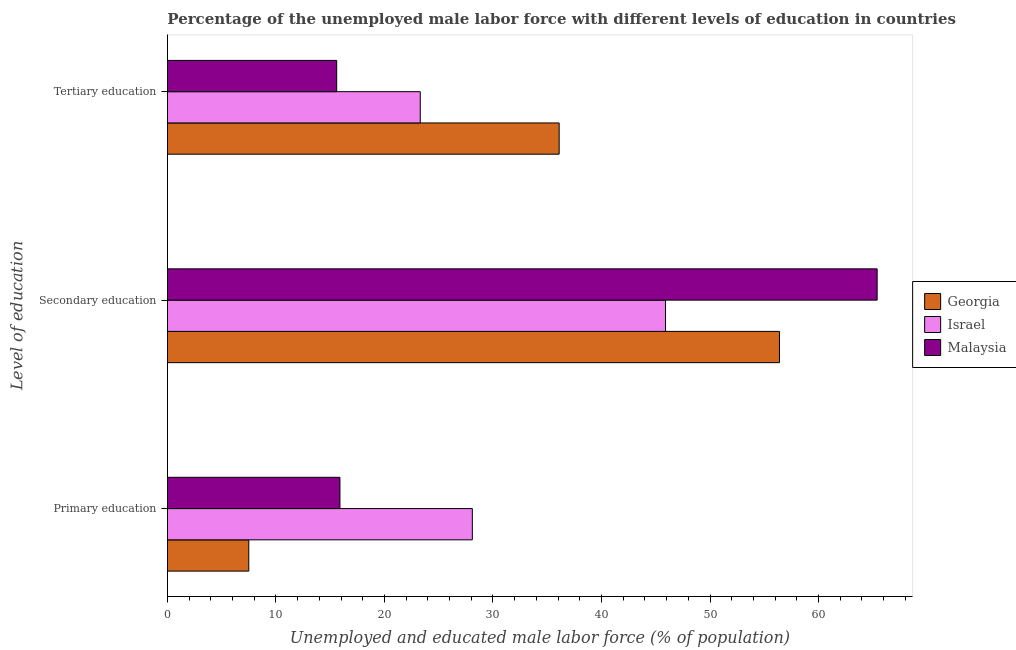How many different coloured bars are there?
Keep it short and to the point. 3. How many groups of bars are there?
Provide a short and direct response. 3. What is the percentage of male labor force who received tertiary education in Israel?
Provide a succinct answer. 23.3. Across all countries, what is the maximum percentage of male labor force who received secondary education?
Provide a succinct answer. 65.4. In which country was the percentage of male labor force who received secondary education maximum?
Offer a terse response. Malaysia. In which country was the percentage of male labor force who received primary education minimum?
Your response must be concise. Georgia. What is the total percentage of male labor force who received primary education in the graph?
Give a very brief answer. 51.5. What is the difference between the percentage of male labor force who received tertiary education in Israel and that in Malaysia?
Your answer should be compact. 7.7. What is the difference between the percentage of male labor force who received primary education in Georgia and the percentage of male labor force who received tertiary education in Israel?
Offer a terse response. -15.8. What is the average percentage of male labor force who received secondary education per country?
Your answer should be compact. 55.9. What is the difference between the percentage of male labor force who received primary education and percentage of male labor force who received secondary education in Malaysia?
Provide a succinct answer. -49.5. In how many countries, is the percentage of male labor force who received primary education greater than 32 %?
Offer a very short reply. 0. What is the ratio of the percentage of male labor force who received secondary education in Malaysia to that in Israel?
Keep it short and to the point. 1.42. Is the difference between the percentage of male labor force who received tertiary education in Malaysia and Georgia greater than the difference between the percentage of male labor force who received secondary education in Malaysia and Georgia?
Provide a short and direct response. No. What is the difference between the highest and the second highest percentage of male labor force who received tertiary education?
Your answer should be very brief. 12.8. What is the difference between the highest and the lowest percentage of male labor force who received secondary education?
Keep it short and to the point. 19.5. What does the 1st bar from the bottom in Primary education represents?
Provide a short and direct response. Georgia. Is it the case that in every country, the sum of the percentage of male labor force who received primary education and percentage of male labor force who received secondary education is greater than the percentage of male labor force who received tertiary education?
Your response must be concise. Yes. How many bars are there?
Give a very brief answer. 9. What is the difference between two consecutive major ticks on the X-axis?
Your answer should be very brief. 10. Does the graph contain any zero values?
Your response must be concise. No. Does the graph contain grids?
Your answer should be very brief. No. Where does the legend appear in the graph?
Your response must be concise. Center right. How are the legend labels stacked?
Your answer should be very brief. Vertical. What is the title of the graph?
Offer a terse response. Percentage of the unemployed male labor force with different levels of education in countries. Does "Germany" appear as one of the legend labels in the graph?
Give a very brief answer. No. What is the label or title of the X-axis?
Ensure brevity in your answer.  Unemployed and educated male labor force (% of population). What is the label or title of the Y-axis?
Provide a short and direct response. Level of education. What is the Unemployed and educated male labor force (% of population) of Georgia in Primary education?
Ensure brevity in your answer.  7.5. What is the Unemployed and educated male labor force (% of population) in Israel in Primary education?
Ensure brevity in your answer.  28.1. What is the Unemployed and educated male labor force (% of population) in Malaysia in Primary education?
Keep it short and to the point. 15.9. What is the Unemployed and educated male labor force (% of population) in Georgia in Secondary education?
Give a very brief answer. 56.4. What is the Unemployed and educated male labor force (% of population) of Israel in Secondary education?
Your response must be concise. 45.9. What is the Unemployed and educated male labor force (% of population) in Malaysia in Secondary education?
Offer a terse response. 65.4. What is the Unemployed and educated male labor force (% of population) of Georgia in Tertiary education?
Your answer should be compact. 36.1. What is the Unemployed and educated male labor force (% of population) in Israel in Tertiary education?
Your answer should be compact. 23.3. What is the Unemployed and educated male labor force (% of population) of Malaysia in Tertiary education?
Your answer should be very brief. 15.6. Across all Level of education, what is the maximum Unemployed and educated male labor force (% of population) of Georgia?
Keep it short and to the point. 56.4. Across all Level of education, what is the maximum Unemployed and educated male labor force (% of population) of Israel?
Provide a short and direct response. 45.9. Across all Level of education, what is the maximum Unemployed and educated male labor force (% of population) of Malaysia?
Offer a very short reply. 65.4. Across all Level of education, what is the minimum Unemployed and educated male labor force (% of population) in Georgia?
Your answer should be very brief. 7.5. Across all Level of education, what is the minimum Unemployed and educated male labor force (% of population) in Israel?
Your response must be concise. 23.3. Across all Level of education, what is the minimum Unemployed and educated male labor force (% of population) of Malaysia?
Provide a short and direct response. 15.6. What is the total Unemployed and educated male labor force (% of population) of Israel in the graph?
Give a very brief answer. 97.3. What is the total Unemployed and educated male labor force (% of population) in Malaysia in the graph?
Your answer should be compact. 96.9. What is the difference between the Unemployed and educated male labor force (% of population) in Georgia in Primary education and that in Secondary education?
Your answer should be compact. -48.9. What is the difference between the Unemployed and educated male labor force (% of population) in Israel in Primary education and that in Secondary education?
Provide a succinct answer. -17.8. What is the difference between the Unemployed and educated male labor force (% of population) in Malaysia in Primary education and that in Secondary education?
Ensure brevity in your answer.  -49.5. What is the difference between the Unemployed and educated male labor force (% of population) of Georgia in Primary education and that in Tertiary education?
Provide a succinct answer. -28.6. What is the difference between the Unemployed and educated male labor force (% of population) of Malaysia in Primary education and that in Tertiary education?
Ensure brevity in your answer.  0.3. What is the difference between the Unemployed and educated male labor force (% of population) of Georgia in Secondary education and that in Tertiary education?
Keep it short and to the point. 20.3. What is the difference between the Unemployed and educated male labor force (% of population) in Israel in Secondary education and that in Tertiary education?
Make the answer very short. 22.6. What is the difference between the Unemployed and educated male labor force (% of population) of Malaysia in Secondary education and that in Tertiary education?
Keep it short and to the point. 49.8. What is the difference between the Unemployed and educated male labor force (% of population) of Georgia in Primary education and the Unemployed and educated male labor force (% of population) of Israel in Secondary education?
Offer a very short reply. -38.4. What is the difference between the Unemployed and educated male labor force (% of population) in Georgia in Primary education and the Unemployed and educated male labor force (% of population) in Malaysia in Secondary education?
Ensure brevity in your answer.  -57.9. What is the difference between the Unemployed and educated male labor force (% of population) in Israel in Primary education and the Unemployed and educated male labor force (% of population) in Malaysia in Secondary education?
Provide a short and direct response. -37.3. What is the difference between the Unemployed and educated male labor force (% of population) of Georgia in Primary education and the Unemployed and educated male labor force (% of population) of Israel in Tertiary education?
Keep it short and to the point. -15.8. What is the difference between the Unemployed and educated male labor force (% of population) of Georgia in Primary education and the Unemployed and educated male labor force (% of population) of Malaysia in Tertiary education?
Keep it short and to the point. -8.1. What is the difference between the Unemployed and educated male labor force (% of population) of Georgia in Secondary education and the Unemployed and educated male labor force (% of population) of Israel in Tertiary education?
Keep it short and to the point. 33.1. What is the difference between the Unemployed and educated male labor force (% of population) in Georgia in Secondary education and the Unemployed and educated male labor force (% of population) in Malaysia in Tertiary education?
Offer a terse response. 40.8. What is the difference between the Unemployed and educated male labor force (% of population) in Israel in Secondary education and the Unemployed and educated male labor force (% of population) in Malaysia in Tertiary education?
Your answer should be very brief. 30.3. What is the average Unemployed and educated male labor force (% of population) of Georgia per Level of education?
Your response must be concise. 33.33. What is the average Unemployed and educated male labor force (% of population) in Israel per Level of education?
Make the answer very short. 32.43. What is the average Unemployed and educated male labor force (% of population) of Malaysia per Level of education?
Your answer should be very brief. 32.3. What is the difference between the Unemployed and educated male labor force (% of population) in Georgia and Unemployed and educated male labor force (% of population) in Israel in Primary education?
Your response must be concise. -20.6. What is the difference between the Unemployed and educated male labor force (% of population) of Georgia and Unemployed and educated male labor force (% of population) of Malaysia in Primary education?
Give a very brief answer. -8.4. What is the difference between the Unemployed and educated male labor force (% of population) of Israel and Unemployed and educated male labor force (% of population) of Malaysia in Primary education?
Your answer should be very brief. 12.2. What is the difference between the Unemployed and educated male labor force (% of population) of Georgia and Unemployed and educated male labor force (% of population) of Malaysia in Secondary education?
Provide a succinct answer. -9. What is the difference between the Unemployed and educated male labor force (% of population) of Israel and Unemployed and educated male labor force (% of population) of Malaysia in Secondary education?
Offer a very short reply. -19.5. What is the difference between the Unemployed and educated male labor force (% of population) in Georgia and Unemployed and educated male labor force (% of population) in Israel in Tertiary education?
Your answer should be compact. 12.8. What is the difference between the Unemployed and educated male labor force (% of population) of Georgia and Unemployed and educated male labor force (% of population) of Malaysia in Tertiary education?
Offer a terse response. 20.5. What is the ratio of the Unemployed and educated male labor force (% of population) of Georgia in Primary education to that in Secondary education?
Your response must be concise. 0.13. What is the ratio of the Unemployed and educated male labor force (% of population) in Israel in Primary education to that in Secondary education?
Your answer should be very brief. 0.61. What is the ratio of the Unemployed and educated male labor force (% of population) of Malaysia in Primary education to that in Secondary education?
Keep it short and to the point. 0.24. What is the ratio of the Unemployed and educated male labor force (% of population) in Georgia in Primary education to that in Tertiary education?
Your answer should be compact. 0.21. What is the ratio of the Unemployed and educated male labor force (% of population) of Israel in Primary education to that in Tertiary education?
Ensure brevity in your answer.  1.21. What is the ratio of the Unemployed and educated male labor force (% of population) in Malaysia in Primary education to that in Tertiary education?
Offer a very short reply. 1.02. What is the ratio of the Unemployed and educated male labor force (% of population) of Georgia in Secondary education to that in Tertiary education?
Your response must be concise. 1.56. What is the ratio of the Unemployed and educated male labor force (% of population) in Israel in Secondary education to that in Tertiary education?
Your answer should be very brief. 1.97. What is the ratio of the Unemployed and educated male labor force (% of population) in Malaysia in Secondary education to that in Tertiary education?
Provide a short and direct response. 4.19. What is the difference between the highest and the second highest Unemployed and educated male labor force (% of population) in Georgia?
Your response must be concise. 20.3. What is the difference between the highest and the second highest Unemployed and educated male labor force (% of population) of Malaysia?
Your answer should be compact. 49.5. What is the difference between the highest and the lowest Unemployed and educated male labor force (% of population) in Georgia?
Your answer should be very brief. 48.9. What is the difference between the highest and the lowest Unemployed and educated male labor force (% of population) of Israel?
Provide a succinct answer. 22.6. What is the difference between the highest and the lowest Unemployed and educated male labor force (% of population) in Malaysia?
Make the answer very short. 49.8. 